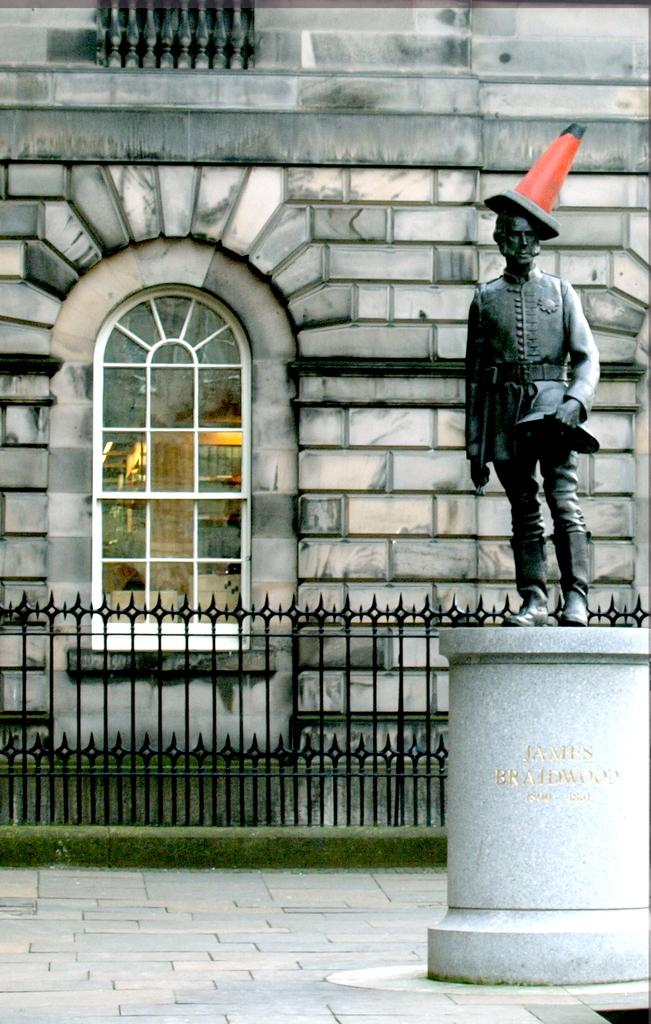What is the main subject of the image? There is a statue of a person in the image. What else can be seen in the image besides the statue? There are other objects in the image. What is visible in the background of the image? There is a fence and a building with a window in the background of the image. How many feet are buried in the cemetery in the image? There is no cemetery present in the image, so it is not possible to determine the number of feet buried there. 